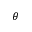<formula> <loc_0><loc_0><loc_500><loc_500>\theta</formula> 